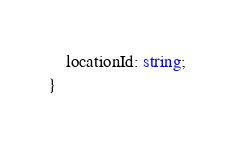Convert code to text. <code><loc_0><loc_0><loc_500><loc_500><_TypeScript_>    locationId: string;
}
</code> 